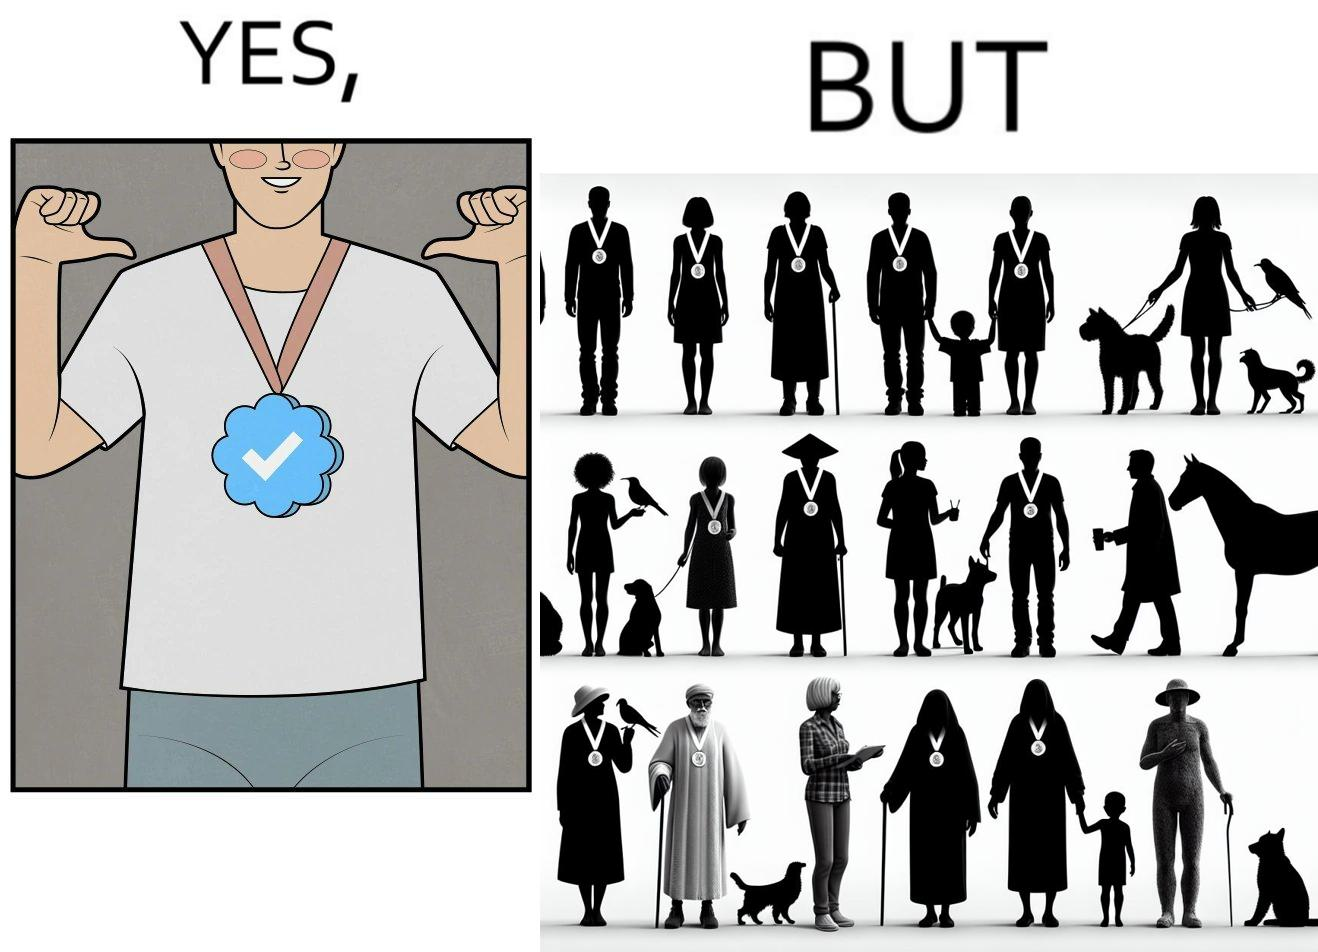What is shown in the left half versus the right half of this image? In the left part of the image: It is a man with a medal In the right part of the image: There are many humans and animals with the same medal 